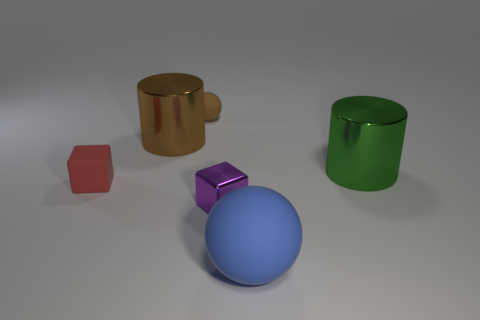Add 2 big red rubber cubes. How many objects exist? 8 Subtract all green cylinders. How many brown balls are left? 1 Add 2 large brown things. How many large brown things are left? 3 Add 6 big matte things. How many big matte things exist? 7 Subtract 0 gray blocks. How many objects are left? 6 Subtract 1 cylinders. How many cylinders are left? 1 Subtract all purple spheres. Subtract all green cylinders. How many spheres are left? 2 Subtract all large green metal balls. Subtract all tiny shiny cubes. How many objects are left? 5 